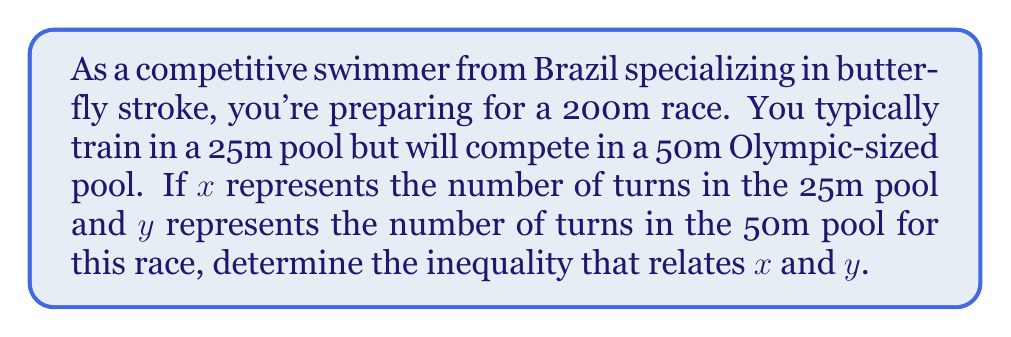Help me with this question. Let's approach this step-by-step:

1) First, let's consider the 25m pool:
   - Total race distance = 200m
   - Pool length = 25m
   - Number of turns = $x$
   - Number of lengths = $x + 1$ (one more than the number of turns)

   We can express this as an equation:
   $$(x + 1) \cdot 25 = 200$$

2) Now, let's consider the 50m pool:
   - Total race distance = 200m
   - Pool length = 50m
   - Number of turns = $y$
   - Number of lengths = $y + 1$

   We can express this as an equation:
   $$(y + 1) \cdot 50 = 200$$

3) From the 25m pool equation:
   $$25x + 25 = 200$$
   $$25x = 175$$
   $$x = 7$$

4) From the 50m pool equation:
   $$50y + 50 = 200$$
   $$50y = 150$$
   $$y = 3$$

5) We can see that $x = 7$ and $y = 3$. To express this as an inequality:
   $$x > y$$

6) More precisely, we can say:
   $$x = 2y + 1$$

This relationship holds true for any race distance that is a multiple of 50m, not just 200m.
Answer: $x > y$ or more precisely, $x = 2y + 1$ 